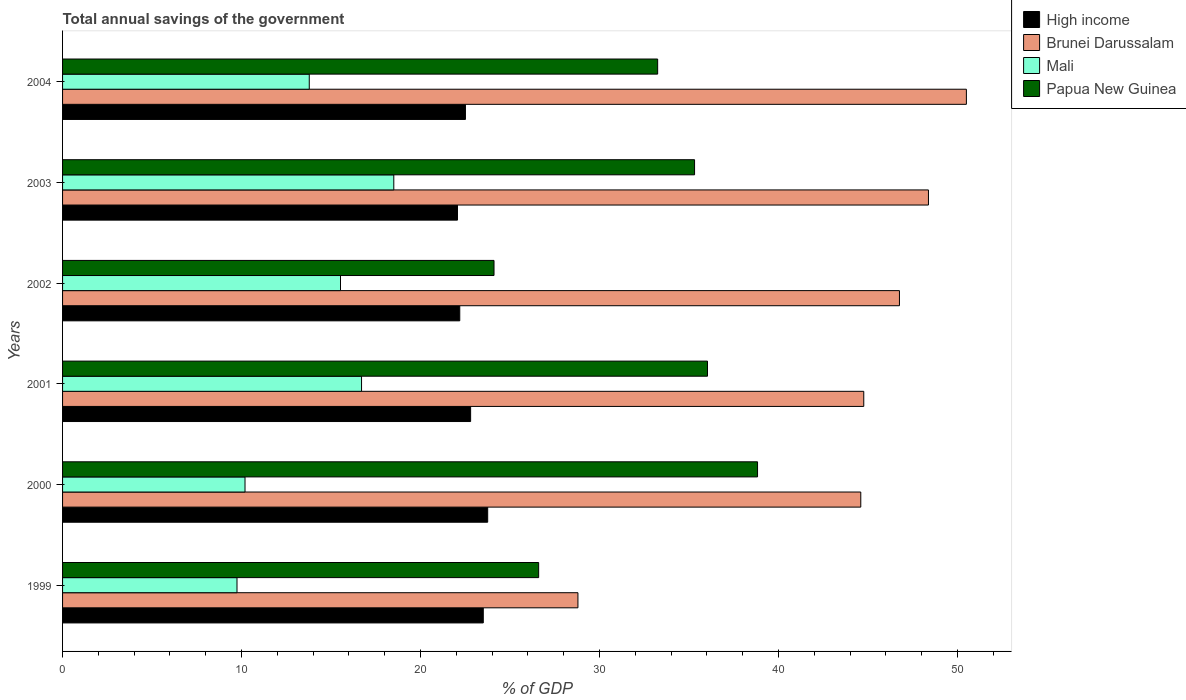Are the number of bars per tick equal to the number of legend labels?
Provide a short and direct response. Yes. How many bars are there on the 4th tick from the top?
Offer a very short reply. 4. What is the total annual savings of the government in Papua New Guinea in 2000?
Offer a terse response. 38.83. Across all years, what is the maximum total annual savings of the government in Mali?
Your answer should be very brief. 18.51. Across all years, what is the minimum total annual savings of the government in High income?
Ensure brevity in your answer.  22.06. In which year was the total annual savings of the government in Papua New Guinea minimum?
Keep it short and to the point. 2002. What is the total total annual savings of the government in High income in the graph?
Your answer should be compact. 136.81. What is the difference between the total annual savings of the government in Brunei Darussalam in 2001 and that in 2004?
Provide a succinct answer. -5.73. What is the difference between the total annual savings of the government in Mali in 2004 and the total annual savings of the government in High income in 2003?
Your answer should be very brief. -8.28. What is the average total annual savings of the government in Mali per year?
Make the answer very short. 14.08. In the year 2000, what is the difference between the total annual savings of the government in Brunei Darussalam and total annual savings of the government in Mali?
Provide a short and direct response. 34.4. What is the ratio of the total annual savings of the government in Papua New Guinea in 2000 to that in 2003?
Your response must be concise. 1.1. Is the total annual savings of the government in Papua New Guinea in 2001 less than that in 2003?
Your answer should be compact. No. Is the difference between the total annual savings of the government in Brunei Darussalam in 1999 and 2003 greater than the difference between the total annual savings of the government in Mali in 1999 and 2003?
Make the answer very short. No. What is the difference between the highest and the second highest total annual savings of the government in Brunei Darussalam?
Your answer should be very brief. 2.12. What is the difference between the highest and the lowest total annual savings of the government in Papua New Guinea?
Offer a very short reply. 14.72. What does the 2nd bar from the bottom in 2000 represents?
Provide a short and direct response. Brunei Darussalam. How many bars are there?
Your answer should be compact. 24. Are all the bars in the graph horizontal?
Ensure brevity in your answer.  Yes. Are the values on the major ticks of X-axis written in scientific E-notation?
Offer a very short reply. No. Does the graph contain any zero values?
Your answer should be very brief. No. Where does the legend appear in the graph?
Your answer should be very brief. Top right. How many legend labels are there?
Offer a terse response. 4. How are the legend labels stacked?
Offer a terse response. Vertical. What is the title of the graph?
Ensure brevity in your answer.  Total annual savings of the government. Does "St. Vincent and the Grenadines" appear as one of the legend labels in the graph?
Give a very brief answer. No. What is the label or title of the X-axis?
Your answer should be very brief. % of GDP. What is the % of GDP of High income in 1999?
Your answer should be very brief. 23.5. What is the % of GDP in Brunei Darussalam in 1999?
Your answer should be very brief. 28.79. What is the % of GDP of Mali in 1999?
Offer a very short reply. 9.75. What is the % of GDP in Papua New Guinea in 1999?
Offer a very short reply. 26.6. What is the % of GDP of High income in 2000?
Your answer should be very brief. 23.75. What is the % of GDP in Brunei Darussalam in 2000?
Provide a succinct answer. 44.59. What is the % of GDP in Mali in 2000?
Your answer should be very brief. 10.19. What is the % of GDP in Papua New Guinea in 2000?
Your answer should be very brief. 38.83. What is the % of GDP of High income in 2001?
Your answer should be very brief. 22.8. What is the % of GDP of Brunei Darussalam in 2001?
Your response must be concise. 44.76. What is the % of GDP in Mali in 2001?
Offer a very short reply. 16.7. What is the % of GDP in Papua New Guinea in 2001?
Ensure brevity in your answer.  36.03. What is the % of GDP in High income in 2002?
Give a very brief answer. 22.19. What is the % of GDP of Brunei Darussalam in 2002?
Your answer should be very brief. 46.76. What is the % of GDP of Mali in 2002?
Your answer should be very brief. 15.53. What is the % of GDP of Papua New Guinea in 2002?
Give a very brief answer. 24.1. What is the % of GDP of High income in 2003?
Your answer should be compact. 22.06. What is the % of GDP in Brunei Darussalam in 2003?
Offer a terse response. 48.38. What is the % of GDP in Mali in 2003?
Provide a succinct answer. 18.51. What is the % of GDP of Papua New Guinea in 2003?
Your answer should be compact. 35.31. What is the % of GDP in High income in 2004?
Provide a short and direct response. 22.51. What is the % of GDP in Brunei Darussalam in 2004?
Offer a very short reply. 50.49. What is the % of GDP in Mali in 2004?
Your response must be concise. 13.78. What is the % of GDP in Papua New Guinea in 2004?
Offer a very short reply. 33.25. Across all years, what is the maximum % of GDP in High income?
Offer a terse response. 23.75. Across all years, what is the maximum % of GDP in Brunei Darussalam?
Provide a short and direct response. 50.49. Across all years, what is the maximum % of GDP in Mali?
Keep it short and to the point. 18.51. Across all years, what is the maximum % of GDP in Papua New Guinea?
Keep it short and to the point. 38.83. Across all years, what is the minimum % of GDP of High income?
Offer a very short reply. 22.06. Across all years, what is the minimum % of GDP of Brunei Darussalam?
Your response must be concise. 28.79. Across all years, what is the minimum % of GDP in Mali?
Ensure brevity in your answer.  9.75. Across all years, what is the minimum % of GDP in Papua New Guinea?
Your answer should be very brief. 24.1. What is the total % of GDP of High income in the graph?
Provide a short and direct response. 136.81. What is the total % of GDP in Brunei Darussalam in the graph?
Your response must be concise. 263.78. What is the total % of GDP of Mali in the graph?
Offer a terse response. 84.46. What is the total % of GDP in Papua New Guinea in the graph?
Ensure brevity in your answer.  194.12. What is the difference between the % of GDP in High income in 1999 and that in 2000?
Give a very brief answer. -0.25. What is the difference between the % of GDP of Brunei Darussalam in 1999 and that in 2000?
Provide a succinct answer. -15.8. What is the difference between the % of GDP of Mali in 1999 and that in 2000?
Offer a very short reply. -0.45. What is the difference between the % of GDP of Papua New Guinea in 1999 and that in 2000?
Provide a short and direct response. -12.23. What is the difference between the % of GDP in High income in 1999 and that in 2001?
Ensure brevity in your answer.  0.71. What is the difference between the % of GDP in Brunei Darussalam in 1999 and that in 2001?
Your answer should be compact. -15.97. What is the difference between the % of GDP of Mali in 1999 and that in 2001?
Give a very brief answer. -6.96. What is the difference between the % of GDP of Papua New Guinea in 1999 and that in 2001?
Offer a very short reply. -9.43. What is the difference between the % of GDP in High income in 1999 and that in 2002?
Offer a very short reply. 1.31. What is the difference between the % of GDP in Brunei Darussalam in 1999 and that in 2002?
Keep it short and to the point. -17.96. What is the difference between the % of GDP of Mali in 1999 and that in 2002?
Keep it short and to the point. -5.78. What is the difference between the % of GDP in Papua New Guinea in 1999 and that in 2002?
Your answer should be compact. 2.49. What is the difference between the % of GDP of High income in 1999 and that in 2003?
Offer a terse response. 1.44. What is the difference between the % of GDP of Brunei Darussalam in 1999 and that in 2003?
Keep it short and to the point. -19.58. What is the difference between the % of GDP in Mali in 1999 and that in 2003?
Provide a short and direct response. -8.76. What is the difference between the % of GDP in Papua New Guinea in 1999 and that in 2003?
Give a very brief answer. -8.71. What is the difference between the % of GDP in Brunei Darussalam in 1999 and that in 2004?
Provide a short and direct response. -21.7. What is the difference between the % of GDP of Mali in 1999 and that in 2004?
Offer a very short reply. -4.04. What is the difference between the % of GDP of Papua New Guinea in 1999 and that in 2004?
Provide a short and direct response. -6.65. What is the difference between the % of GDP in High income in 2000 and that in 2001?
Provide a succinct answer. 0.95. What is the difference between the % of GDP of Brunei Darussalam in 2000 and that in 2001?
Make the answer very short. -0.17. What is the difference between the % of GDP in Mali in 2000 and that in 2001?
Offer a terse response. -6.51. What is the difference between the % of GDP of Papua New Guinea in 2000 and that in 2001?
Provide a succinct answer. 2.8. What is the difference between the % of GDP of High income in 2000 and that in 2002?
Provide a succinct answer. 1.56. What is the difference between the % of GDP of Brunei Darussalam in 2000 and that in 2002?
Offer a very short reply. -2.16. What is the difference between the % of GDP of Mali in 2000 and that in 2002?
Your answer should be very brief. -5.33. What is the difference between the % of GDP of Papua New Guinea in 2000 and that in 2002?
Make the answer very short. 14.72. What is the difference between the % of GDP of High income in 2000 and that in 2003?
Your answer should be very brief. 1.69. What is the difference between the % of GDP of Brunei Darussalam in 2000 and that in 2003?
Give a very brief answer. -3.78. What is the difference between the % of GDP in Mali in 2000 and that in 2003?
Keep it short and to the point. -8.31. What is the difference between the % of GDP in Papua New Guinea in 2000 and that in 2003?
Provide a short and direct response. 3.52. What is the difference between the % of GDP in High income in 2000 and that in 2004?
Your response must be concise. 1.24. What is the difference between the % of GDP in Mali in 2000 and that in 2004?
Provide a succinct answer. -3.59. What is the difference between the % of GDP of Papua New Guinea in 2000 and that in 2004?
Make the answer very short. 5.58. What is the difference between the % of GDP in High income in 2001 and that in 2002?
Offer a very short reply. 0.61. What is the difference between the % of GDP of Brunei Darussalam in 2001 and that in 2002?
Give a very brief answer. -1.99. What is the difference between the % of GDP in Mali in 2001 and that in 2002?
Give a very brief answer. 1.18. What is the difference between the % of GDP of Papua New Guinea in 2001 and that in 2002?
Keep it short and to the point. 11.93. What is the difference between the % of GDP of High income in 2001 and that in 2003?
Your response must be concise. 0.73. What is the difference between the % of GDP of Brunei Darussalam in 2001 and that in 2003?
Ensure brevity in your answer.  -3.61. What is the difference between the % of GDP in Mali in 2001 and that in 2003?
Your response must be concise. -1.8. What is the difference between the % of GDP of Papua New Guinea in 2001 and that in 2003?
Provide a short and direct response. 0.72. What is the difference between the % of GDP of High income in 2001 and that in 2004?
Your response must be concise. 0.29. What is the difference between the % of GDP in Brunei Darussalam in 2001 and that in 2004?
Ensure brevity in your answer.  -5.73. What is the difference between the % of GDP in Mali in 2001 and that in 2004?
Offer a very short reply. 2.92. What is the difference between the % of GDP in Papua New Guinea in 2001 and that in 2004?
Your response must be concise. 2.79. What is the difference between the % of GDP of High income in 2002 and that in 2003?
Your answer should be very brief. 0.13. What is the difference between the % of GDP in Brunei Darussalam in 2002 and that in 2003?
Offer a terse response. -1.62. What is the difference between the % of GDP of Mali in 2002 and that in 2003?
Provide a short and direct response. -2.98. What is the difference between the % of GDP in Papua New Guinea in 2002 and that in 2003?
Offer a very short reply. -11.2. What is the difference between the % of GDP in High income in 2002 and that in 2004?
Your answer should be compact. -0.32. What is the difference between the % of GDP in Brunei Darussalam in 2002 and that in 2004?
Keep it short and to the point. -3.74. What is the difference between the % of GDP in Mali in 2002 and that in 2004?
Provide a succinct answer. 1.75. What is the difference between the % of GDP in Papua New Guinea in 2002 and that in 2004?
Your answer should be compact. -9.14. What is the difference between the % of GDP of High income in 2003 and that in 2004?
Your answer should be compact. -0.44. What is the difference between the % of GDP of Brunei Darussalam in 2003 and that in 2004?
Ensure brevity in your answer.  -2.12. What is the difference between the % of GDP in Mali in 2003 and that in 2004?
Ensure brevity in your answer.  4.72. What is the difference between the % of GDP of Papua New Guinea in 2003 and that in 2004?
Your answer should be very brief. 2.06. What is the difference between the % of GDP in High income in 1999 and the % of GDP in Brunei Darussalam in 2000?
Ensure brevity in your answer.  -21.09. What is the difference between the % of GDP of High income in 1999 and the % of GDP of Mali in 2000?
Your answer should be very brief. 13.31. What is the difference between the % of GDP in High income in 1999 and the % of GDP in Papua New Guinea in 2000?
Give a very brief answer. -15.32. What is the difference between the % of GDP of Brunei Darussalam in 1999 and the % of GDP of Mali in 2000?
Give a very brief answer. 18.6. What is the difference between the % of GDP of Brunei Darussalam in 1999 and the % of GDP of Papua New Guinea in 2000?
Provide a succinct answer. -10.03. What is the difference between the % of GDP in Mali in 1999 and the % of GDP in Papua New Guinea in 2000?
Make the answer very short. -29.08. What is the difference between the % of GDP in High income in 1999 and the % of GDP in Brunei Darussalam in 2001?
Ensure brevity in your answer.  -21.26. What is the difference between the % of GDP in High income in 1999 and the % of GDP in Mali in 2001?
Your response must be concise. 6.8. What is the difference between the % of GDP in High income in 1999 and the % of GDP in Papua New Guinea in 2001?
Keep it short and to the point. -12.53. What is the difference between the % of GDP in Brunei Darussalam in 1999 and the % of GDP in Mali in 2001?
Offer a very short reply. 12.09. What is the difference between the % of GDP of Brunei Darussalam in 1999 and the % of GDP of Papua New Guinea in 2001?
Your answer should be very brief. -7.24. What is the difference between the % of GDP in Mali in 1999 and the % of GDP in Papua New Guinea in 2001?
Offer a terse response. -26.29. What is the difference between the % of GDP of High income in 1999 and the % of GDP of Brunei Darussalam in 2002?
Your answer should be compact. -23.25. What is the difference between the % of GDP in High income in 1999 and the % of GDP in Mali in 2002?
Your answer should be very brief. 7.98. What is the difference between the % of GDP in High income in 1999 and the % of GDP in Papua New Guinea in 2002?
Provide a succinct answer. -0.6. What is the difference between the % of GDP in Brunei Darussalam in 1999 and the % of GDP in Mali in 2002?
Your response must be concise. 13.27. What is the difference between the % of GDP in Brunei Darussalam in 1999 and the % of GDP in Papua New Guinea in 2002?
Keep it short and to the point. 4.69. What is the difference between the % of GDP of Mali in 1999 and the % of GDP of Papua New Guinea in 2002?
Your answer should be compact. -14.36. What is the difference between the % of GDP of High income in 1999 and the % of GDP of Brunei Darussalam in 2003?
Offer a terse response. -24.87. What is the difference between the % of GDP of High income in 1999 and the % of GDP of Mali in 2003?
Your answer should be very brief. 5. What is the difference between the % of GDP of High income in 1999 and the % of GDP of Papua New Guinea in 2003?
Your response must be concise. -11.8. What is the difference between the % of GDP in Brunei Darussalam in 1999 and the % of GDP in Mali in 2003?
Ensure brevity in your answer.  10.29. What is the difference between the % of GDP in Brunei Darussalam in 1999 and the % of GDP in Papua New Guinea in 2003?
Provide a succinct answer. -6.52. What is the difference between the % of GDP in Mali in 1999 and the % of GDP in Papua New Guinea in 2003?
Your answer should be very brief. -25.56. What is the difference between the % of GDP in High income in 1999 and the % of GDP in Brunei Darussalam in 2004?
Make the answer very short. -26.99. What is the difference between the % of GDP in High income in 1999 and the % of GDP in Mali in 2004?
Provide a succinct answer. 9.72. What is the difference between the % of GDP of High income in 1999 and the % of GDP of Papua New Guinea in 2004?
Your answer should be compact. -9.74. What is the difference between the % of GDP of Brunei Darussalam in 1999 and the % of GDP of Mali in 2004?
Make the answer very short. 15.01. What is the difference between the % of GDP of Brunei Darussalam in 1999 and the % of GDP of Papua New Guinea in 2004?
Provide a succinct answer. -4.45. What is the difference between the % of GDP of Mali in 1999 and the % of GDP of Papua New Guinea in 2004?
Offer a very short reply. -23.5. What is the difference between the % of GDP in High income in 2000 and the % of GDP in Brunei Darussalam in 2001?
Your answer should be very brief. -21.01. What is the difference between the % of GDP of High income in 2000 and the % of GDP of Mali in 2001?
Ensure brevity in your answer.  7.05. What is the difference between the % of GDP in High income in 2000 and the % of GDP in Papua New Guinea in 2001?
Offer a very short reply. -12.28. What is the difference between the % of GDP in Brunei Darussalam in 2000 and the % of GDP in Mali in 2001?
Your response must be concise. 27.89. What is the difference between the % of GDP of Brunei Darussalam in 2000 and the % of GDP of Papua New Guinea in 2001?
Offer a terse response. 8.56. What is the difference between the % of GDP of Mali in 2000 and the % of GDP of Papua New Guinea in 2001?
Offer a terse response. -25.84. What is the difference between the % of GDP of High income in 2000 and the % of GDP of Brunei Darussalam in 2002?
Your response must be concise. -23. What is the difference between the % of GDP in High income in 2000 and the % of GDP in Mali in 2002?
Offer a very short reply. 8.22. What is the difference between the % of GDP in High income in 2000 and the % of GDP in Papua New Guinea in 2002?
Your answer should be very brief. -0.35. What is the difference between the % of GDP in Brunei Darussalam in 2000 and the % of GDP in Mali in 2002?
Offer a very short reply. 29.07. What is the difference between the % of GDP in Brunei Darussalam in 2000 and the % of GDP in Papua New Guinea in 2002?
Your answer should be very brief. 20.49. What is the difference between the % of GDP in Mali in 2000 and the % of GDP in Papua New Guinea in 2002?
Offer a terse response. -13.91. What is the difference between the % of GDP in High income in 2000 and the % of GDP in Brunei Darussalam in 2003?
Keep it short and to the point. -24.62. What is the difference between the % of GDP of High income in 2000 and the % of GDP of Mali in 2003?
Make the answer very short. 5.25. What is the difference between the % of GDP of High income in 2000 and the % of GDP of Papua New Guinea in 2003?
Give a very brief answer. -11.56. What is the difference between the % of GDP in Brunei Darussalam in 2000 and the % of GDP in Mali in 2003?
Ensure brevity in your answer.  26.09. What is the difference between the % of GDP in Brunei Darussalam in 2000 and the % of GDP in Papua New Guinea in 2003?
Offer a terse response. 9.29. What is the difference between the % of GDP in Mali in 2000 and the % of GDP in Papua New Guinea in 2003?
Keep it short and to the point. -25.12. What is the difference between the % of GDP in High income in 2000 and the % of GDP in Brunei Darussalam in 2004?
Your answer should be compact. -26.74. What is the difference between the % of GDP in High income in 2000 and the % of GDP in Mali in 2004?
Make the answer very short. 9.97. What is the difference between the % of GDP of High income in 2000 and the % of GDP of Papua New Guinea in 2004?
Your answer should be very brief. -9.5. What is the difference between the % of GDP of Brunei Darussalam in 2000 and the % of GDP of Mali in 2004?
Ensure brevity in your answer.  30.81. What is the difference between the % of GDP of Brunei Darussalam in 2000 and the % of GDP of Papua New Guinea in 2004?
Provide a short and direct response. 11.35. What is the difference between the % of GDP in Mali in 2000 and the % of GDP in Papua New Guinea in 2004?
Provide a short and direct response. -23.05. What is the difference between the % of GDP in High income in 2001 and the % of GDP in Brunei Darussalam in 2002?
Your answer should be very brief. -23.96. What is the difference between the % of GDP of High income in 2001 and the % of GDP of Mali in 2002?
Your response must be concise. 7.27. What is the difference between the % of GDP in High income in 2001 and the % of GDP in Papua New Guinea in 2002?
Provide a succinct answer. -1.31. What is the difference between the % of GDP in Brunei Darussalam in 2001 and the % of GDP in Mali in 2002?
Your response must be concise. 29.23. What is the difference between the % of GDP of Brunei Darussalam in 2001 and the % of GDP of Papua New Guinea in 2002?
Give a very brief answer. 20.66. What is the difference between the % of GDP in Mali in 2001 and the % of GDP in Papua New Guinea in 2002?
Offer a terse response. -7.4. What is the difference between the % of GDP of High income in 2001 and the % of GDP of Brunei Darussalam in 2003?
Make the answer very short. -25.58. What is the difference between the % of GDP in High income in 2001 and the % of GDP in Mali in 2003?
Provide a succinct answer. 4.29. What is the difference between the % of GDP in High income in 2001 and the % of GDP in Papua New Guinea in 2003?
Keep it short and to the point. -12.51. What is the difference between the % of GDP in Brunei Darussalam in 2001 and the % of GDP in Mali in 2003?
Your answer should be very brief. 26.26. What is the difference between the % of GDP of Brunei Darussalam in 2001 and the % of GDP of Papua New Guinea in 2003?
Your answer should be compact. 9.45. What is the difference between the % of GDP in Mali in 2001 and the % of GDP in Papua New Guinea in 2003?
Provide a short and direct response. -18.6. What is the difference between the % of GDP in High income in 2001 and the % of GDP in Brunei Darussalam in 2004?
Your response must be concise. -27.7. What is the difference between the % of GDP in High income in 2001 and the % of GDP in Mali in 2004?
Offer a very short reply. 9.01. What is the difference between the % of GDP of High income in 2001 and the % of GDP of Papua New Guinea in 2004?
Keep it short and to the point. -10.45. What is the difference between the % of GDP in Brunei Darussalam in 2001 and the % of GDP in Mali in 2004?
Your answer should be compact. 30.98. What is the difference between the % of GDP in Brunei Darussalam in 2001 and the % of GDP in Papua New Guinea in 2004?
Your answer should be compact. 11.52. What is the difference between the % of GDP of Mali in 2001 and the % of GDP of Papua New Guinea in 2004?
Make the answer very short. -16.54. What is the difference between the % of GDP of High income in 2002 and the % of GDP of Brunei Darussalam in 2003?
Your answer should be compact. -26.19. What is the difference between the % of GDP in High income in 2002 and the % of GDP in Mali in 2003?
Ensure brevity in your answer.  3.68. What is the difference between the % of GDP in High income in 2002 and the % of GDP in Papua New Guinea in 2003?
Make the answer very short. -13.12. What is the difference between the % of GDP of Brunei Darussalam in 2002 and the % of GDP of Mali in 2003?
Provide a succinct answer. 28.25. What is the difference between the % of GDP of Brunei Darussalam in 2002 and the % of GDP of Papua New Guinea in 2003?
Make the answer very short. 11.45. What is the difference between the % of GDP of Mali in 2002 and the % of GDP of Papua New Guinea in 2003?
Your answer should be very brief. -19.78. What is the difference between the % of GDP of High income in 2002 and the % of GDP of Brunei Darussalam in 2004?
Offer a very short reply. -28.3. What is the difference between the % of GDP in High income in 2002 and the % of GDP in Mali in 2004?
Offer a terse response. 8.41. What is the difference between the % of GDP in High income in 2002 and the % of GDP in Papua New Guinea in 2004?
Offer a very short reply. -11.06. What is the difference between the % of GDP of Brunei Darussalam in 2002 and the % of GDP of Mali in 2004?
Make the answer very short. 32.97. What is the difference between the % of GDP of Brunei Darussalam in 2002 and the % of GDP of Papua New Guinea in 2004?
Make the answer very short. 13.51. What is the difference between the % of GDP in Mali in 2002 and the % of GDP in Papua New Guinea in 2004?
Keep it short and to the point. -17.72. What is the difference between the % of GDP in High income in 2003 and the % of GDP in Brunei Darussalam in 2004?
Your response must be concise. -28.43. What is the difference between the % of GDP of High income in 2003 and the % of GDP of Mali in 2004?
Offer a terse response. 8.28. What is the difference between the % of GDP of High income in 2003 and the % of GDP of Papua New Guinea in 2004?
Make the answer very short. -11.18. What is the difference between the % of GDP in Brunei Darussalam in 2003 and the % of GDP in Mali in 2004?
Provide a succinct answer. 34.59. What is the difference between the % of GDP in Brunei Darussalam in 2003 and the % of GDP in Papua New Guinea in 2004?
Make the answer very short. 15.13. What is the difference between the % of GDP in Mali in 2003 and the % of GDP in Papua New Guinea in 2004?
Your response must be concise. -14.74. What is the average % of GDP in High income per year?
Keep it short and to the point. 22.8. What is the average % of GDP of Brunei Darussalam per year?
Your response must be concise. 43.96. What is the average % of GDP in Mali per year?
Give a very brief answer. 14.08. What is the average % of GDP of Papua New Guinea per year?
Offer a terse response. 32.35. In the year 1999, what is the difference between the % of GDP in High income and % of GDP in Brunei Darussalam?
Provide a succinct answer. -5.29. In the year 1999, what is the difference between the % of GDP of High income and % of GDP of Mali?
Offer a very short reply. 13.76. In the year 1999, what is the difference between the % of GDP of High income and % of GDP of Papua New Guinea?
Give a very brief answer. -3.09. In the year 1999, what is the difference between the % of GDP of Brunei Darussalam and % of GDP of Mali?
Keep it short and to the point. 19.05. In the year 1999, what is the difference between the % of GDP of Brunei Darussalam and % of GDP of Papua New Guinea?
Ensure brevity in your answer.  2.19. In the year 1999, what is the difference between the % of GDP in Mali and % of GDP in Papua New Guinea?
Offer a very short reply. -16.85. In the year 2000, what is the difference between the % of GDP in High income and % of GDP in Brunei Darussalam?
Offer a terse response. -20.84. In the year 2000, what is the difference between the % of GDP in High income and % of GDP in Mali?
Make the answer very short. 13.56. In the year 2000, what is the difference between the % of GDP in High income and % of GDP in Papua New Guinea?
Your response must be concise. -15.08. In the year 2000, what is the difference between the % of GDP in Brunei Darussalam and % of GDP in Mali?
Keep it short and to the point. 34.4. In the year 2000, what is the difference between the % of GDP of Brunei Darussalam and % of GDP of Papua New Guinea?
Offer a terse response. 5.77. In the year 2000, what is the difference between the % of GDP in Mali and % of GDP in Papua New Guinea?
Provide a short and direct response. -28.63. In the year 2001, what is the difference between the % of GDP of High income and % of GDP of Brunei Darussalam?
Keep it short and to the point. -21.96. In the year 2001, what is the difference between the % of GDP in High income and % of GDP in Mali?
Your answer should be compact. 6.09. In the year 2001, what is the difference between the % of GDP in High income and % of GDP in Papua New Guinea?
Provide a short and direct response. -13.23. In the year 2001, what is the difference between the % of GDP of Brunei Darussalam and % of GDP of Mali?
Offer a very short reply. 28.06. In the year 2001, what is the difference between the % of GDP of Brunei Darussalam and % of GDP of Papua New Guinea?
Offer a very short reply. 8.73. In the year 2001, what is the difference between the % of GDP of Mali and % of GDP of Papua New Guinea?
Offer a terse response. -19.33. In the year 2002, what is the difference between the % of GDP in High income and % of GDP in Brunei Darussalam?
Provide a short and direct response. -24.57. In the year 2002, what is the difference between the % of GDP in High income and % of GDP in Mali?
Your answer should be compact. 6.66. In the year 2002, what is the difference between the % of GDP in High income and % of GDP in Papua New Guinea?
Make the answer very short. -1.91. In the year 2002, what is the difference between the % of GDP of Brunei Darussalam and % of GDP of Mali?
Provide a short and direct response. 31.23. In the year 2002, what is the difference between the % of GDP of Brunei Darussalam and % of GDP of Papua New Guinea?
Your answer should be compact. 22.65. In the year 2002, what is the difference between the % of GDP in Mali and % of GDP in Papua New Guinea?
Your response must be concise. -8.58. In the year 2003, what is the difference between the % of GDP of High income and % of GDP of Brunei Darussalam?
Give a very brief answer. -26.31. In the year 2003, what is the difference between the % of GDP in High income and % of GDP in Mali?
Provide a short and direct response. 3.56. In the year 2003, what is the difference between the % of GDP in High income and % of GDP in Papua New Guinea?
Ensure brevity in your answer.  -13.24. In the year 2003, what is the difference between the % of GDP of Brunei Darussalam and % of GDP of Mali?
Your answer should be very brief. 29.87. In the year 2003, what is the difference between the % of GDP in Brunei Darussalam and % of GDP in Papua New Guinea?
Make the answer very short. 13.07. In the year 2003, what is the difference between the % of GDP in Mali and % of GDP in Papua New Guinea?
Ensure brevity in your answer.  -16.8. In the year 2004, what is the difference between the % of GDP in High income and % of GDP in Brunei Darussalam?
Your answer should be compact. -27.99. In the year 2004, what is the difference between the % of GDP in High income and % of GDP in Mali?
Give a very brief answer. 8.72. In the year 2004, what is the difference between the % of GDP in High income and % of GDP in Papua New Guinea?
Provide a short and direct response. -10.74. In the year 2004, what is the difference between the % of GDP in Brunei Darussalam and % of GDP in Mali?
Keep it short and to the point. 36.71. In the year 2004, what is the difference between the % of GDP in Brunei Darussalam and % of GDP in Papua New Guinea?
Provide a succinct answer. 17.25. In the year 2004, what is the difference between the % of GDP of Mali and % of GDP of Papua New Guinea?
Your response must be concise. -19.46. What is the ratio of the % of GDP in High income in 1999 to that in 2000?
Ensure brevity in your answer.  0.99. What is the ratio of the % of GDP in Brunei Darussalam in 1999 to that in 2000?
Your answer should be very brief. 0.65. What is the ratio of the % of GDP of Mali in 1999 to that in 2000?
Your answer should be very brief. 0.96. What is the ratio of the % of GDP in Papua New Guinea in 1999 to that in 2000?
Offer a very short reply. 0.69. What is the ratio of the % of GDP in High income in 1999 to that in 2001?
Keep it short and to the point. 1.03. What is the ratio of the % of GDP in Brunei Darussalam in 1999 to that in 2001?
Provide a succinct answer. 0.64. What is the ratio of the % of GDP in Mali in 1999 to that in 2001?
Offer a very short reply. 0.58. What is the ratio of the % of GDP in Papua New Guinea in 1999 to that in 2001?
Your answer should be very brief. 0.74. What is the ratio of the % of GDP of High income in 1999 to that in 2002?
Provide a short and direct response. 1.06. What is the ratio of the % of GDP in Brunei Darussalam in 1999 to that in 2002?
Offer a terse response. 0.62. What is the ratio of the % of GDP in Mali in 1999 to that in 2002?
Ensure brevity in your answer.  0.63. What is the ratio of the % of GDP in Papua New Guinea in 1999 to that in 2002?
Provide a short and direct response. 1.1. What is the ratio of the % of GDP in High income in 1999 to that in 2003?
Your answer should be very brief. 1.07. What is the ratio of the % of GDP of Brunei Darussalam in 1999 to that in 2003?
Your answer should be compact. 0.6. What is the ratio of the % of GDP of Mali in 1999 to that in 2003?
Provide a succinct answer. 0.53. What is the ratio of the % of GDP of Papua New Guinea in 1999 to that in 2003?
Your response must be concise. 0.75. What is the ratio of the % of GDP of High income in 1999 to that in 2004?
Your answer should be very brief. 1.04. What is the ratio of the % of GDP in Brunei Darussalam in 1999 to that in 2004?
Provide a succinct answer. 0.57. What is the ratio of the % of GDP of Mali in 1999 to that in 2004?
Your answer should be very brief. 0.71. What is the ratio of the % of GDP of Papua New Guinea in 1999 to that in 2004?
Give a very brief answer. 0.8. What is the ratio of the % of GDP of High income in 2000 to that in 2001?
Your answer should be very brief. 1.04. What is the ratio of the % of GDP in Mali in 2000 to that in 2001?
Make the answer very short. 0.61. What is the ratio of the % of GDP in Papua New Guinea in 2000 to that in 2001?
Offer a terse response. 1.08. What is the ratio of the % of GDP of High income in 2000 to that in 2002?
Your answer should be compact. 1.07. What is the ratio of the % of GDP of Brunei Darussalam in 2000 to that in 2002?
Give a very brief answer. 0.95. What is the ratio of the % of GDP in Mali in 2000 to that in 2002?
Offer a terse response. 0.66. What is the ratio of the % of GDP in Papua New Guinea in 2000 to that in 2002?
Provide a short and direct response. 1.61. What is the ratio of the % of GDP in High income in 2000 to that in 2003?
Your response must be concise. 1.08. What is the ratio of the % of GDP of Brunei Darussalam in 2000 to that in 2003?
Your response must be concise. 0.92. What is the ratio of the % of GDP of Mali in 2000 to that in 2003?
Offer a very short reply. 0.55. What is the ratio of the % of GDP in Papua New Guinea in 2000 to that in 2003?
Provide a short and direct response. 1.1. What is the ratio of the % of GDP in High income in 2000 to that in 2004?
Provide a succinct answer. 1.06. What is the ratio of the % of GDP of Brunei Darussalam in 2000 to that in 2004?
Give a very brief answer. 0.88. What is the ratio of the % of GDP of Mali in 2000 to that in 2004?
Provide a short and direct response. 0.74. What is the ratio of the % of GDP of Papua New Guinea in 2000 to that in 2004?
Keep it short and to the point. 1.17. What is the ratio of the % of GDP in High income in 2001 to that in 2002?
Your response must be concise. 1.03. What is the ratio of the % of GDP in Brunei Darussalam in 2001 to that in 2002?
Provide a short and direct response. 0.96. What is the ratio of the % of GDP of Mali in 2001 to that in 2002?
Your answer should be very brief. 1.08. What is the ratio of the % of GDP in Papua New Guinea in 2001 to that in 2002?
Make the answer very short. 1.49. What is the ratio of the % of GDP of High income in 2001 to that in 2003?
Offer a terse response. 1.03. What is the ratio of the % of GDP of Brunei Darussalam in 2001 to that in 2003?
Give a very brief answer. 0.93. What is the ratio of the % of GDP in Mali in 2001 to that in 2003?
Offer a terse response. 0.9. What is the ratio of the % of GDP in Papua New Guinea in 2001 to that in 2003?
Provide a succinct answer. 1.02. What is the ratio of the % of GDP of High income in 2001 to that in 2004?
Keep it short and to the point. 1.01. What is the ratio of the % of GDP of Brunei Darussalam in 2001 to that in 2004?
Make the answer very short. 0.89. What is the ratio of the % of GDP in Mali in 2001 to that in 2004?
Provide a succinct answer. 1.21. What is the ratio of the % of GDP in Papua New Guinea in 2001 to that in 2004?
Ensure brevity in your answer.  1.08. What is the ratio of the % of GDP of Brunei Darussalam in 2002 to that in 2003?
Provide a succinct answer. 0.97. What is the ratio of the % of GDP of Mali in 2002 to that in 2003?
Provide a short and direct response. 0.84. What is the ratio of the % of GDP of Papua New Guinea in 2002 to that in 2003?
Your response must be concise. 0.68. What is the ratio of the % of GDP in High income in 2002 to that in 2004?
Provide a succinct answer. 0.99. What is the ratio of the % of GDP in Brunei Darussalam in 2002 to that in 2004?
Provide a succinct answer. 0.93. What is the ratio of the % of GDP in Mali in 2002 to that in 2004?
Your answer should be very brief. 1.13. What is the ratio of the % of GDP in Papua New Guinea in 2002 to that in 2004?
Your answer should be compact. 0.72. What is the ratio of the % of GDP of High income in 2003 to that in 2004?
Provide a succinct answer. 0.98. What is the ratio of the % of GDP in Brunei Darussalam in 2003 to that in 2004?
Give a very brief answer. 0.96. What is the ratio of the % of GDP in Mali in 2003 to that in 2004?
Give a very brief answer. 1.34. What is the ratio of the % of GDP in Papua New Guinea in 2003 to that in 2004?
Your response must be concise. 1.06. What is the difference between the highest and the second highest % of GDP in High income?
Make the answer very short. 0.25. What is the difference between the highest and the second highest % of GDP of Brunei Darussalam?
Ensure brevity in your answer.  2.12. What is the difference between the highest and the second highest % of GDP in Mali?
Give a very brief answer. 1.8. What is the difference between the highest and the second highest % of GDP in Papua New Guinea?
Your answer should be very brief. 2.8. What is the difference between the highest and the lowest % of GDP in High income?
Provide a short and direct response. 1.69. What is the difference between the highest and the lowest % of GDP in Brunei Darussalam?
Provide a short and direct response. 21.7. What is the difference between the highest and the lowest % of GDP in Mali?
Give a very brief answer. 8.76. What is the difference between the highest and the lowest % of GDP in Papua New Guinea?
Your answer should be compact. 14.72. 